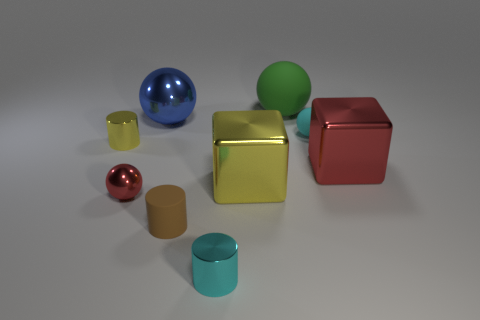How many other objects are the same size as the blue shiny object?
Offer a terse response. 3. The metal object that is behind the red metallic cube and left of the large blue sphere has what shape?
Your answer should be compact. Cylinder. There is a matte ball that is the same size as the blue object; what is its color?
Make the answer very short. Green. Do the metal sphere in front of the red metal cube and the blue metallic object to the left of the cyan rubber object have the same size?
Your answer should be compact. No. How big is the sphere in front of the yellow thing on the left side of the tiny cyan object that is in front of the yellow cylinder?
Make the answer very short. Small. There is a matte object in front of the large object right of the cyan rubber ball; what shape is it?
Provide a short and direct response. Cylinder. There is a sphere in front of the small yellow cylinder; is it the same color as the small rubber cylinder?
Your answer should be compact. No. What color is the metal thing that is both in front of the big yellow metallic cube and to the left of the brown rubber object?
Your answer should be very brief. Red. Are there any small brown cylinders that have the same material as the large yellow object?
Your answer should be compact. No. How big is the cyan shiny thing?
Give a very brief answer. Small. 